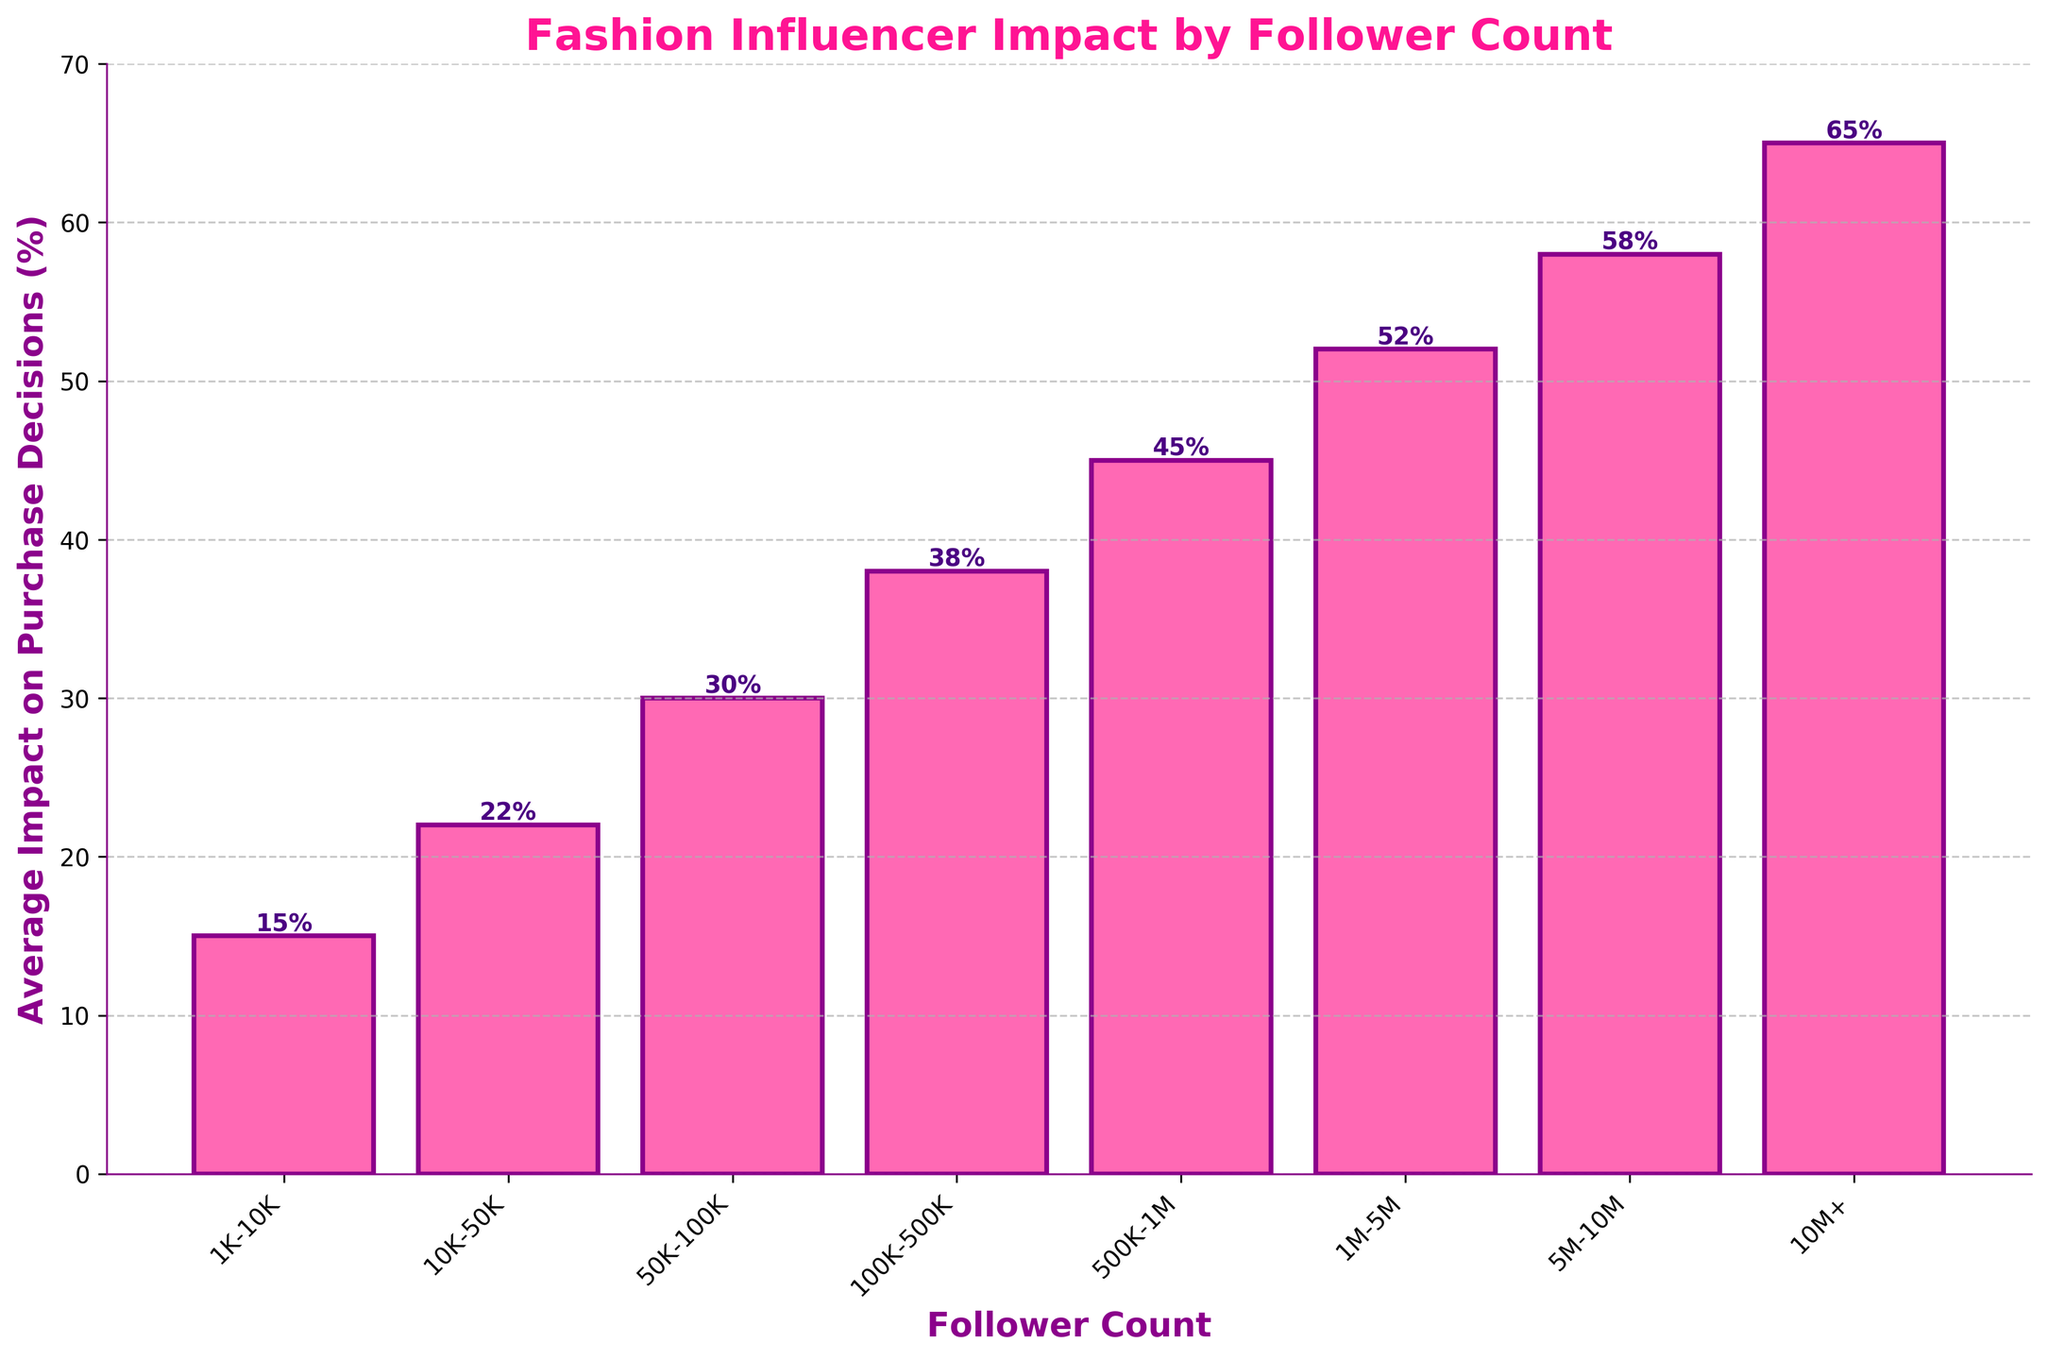What is the average impact on purchase decisions for influencers with 100K-500K followers? The bar representing influencers with 100K-500K followers has a height of 38%, which means the average impact on purchase decisions for this group is 38%.
Answer: 38% Which follower count range has the highest impact on purchase decisions? Looking at the heights of the bars, the bar for the follower count range 10M+ has the highest value at 65%.
Answer: 10M+ How many percentage points higher is the impact for influencers with 1M-5M followers compared to those with 10K-50K followers? The bar for 1M-5M followers shows 52%, and the bar for 10K-50K followers shows 22%. The difference is 52% - 22% = 30%.
Answer: 30% What is the total impact percentage when combining the effect of influencers with 1K-10K and 500K-1M follower counts? The figure shows 15% for 1K-10K followers and 45% for 500K-1M followers. Adding these gives 15% + 45% = 60%.
Answer: 60% Which follower count range shows an impact percentage closest to the median of all provided impact percentages? Listing the percentages: 15, 22, 30, 38, 45, 52, 58, 65. The median is the average of the two middle values (38 and 45). (38+45)/2 = 41.5. The closest range is 100K-500K with 38%.
Answer: 100K-500K Is the impact on purchase decisions of influencers with 5M-10M followers greater than those with 100K-500K followers by more than 20 percentage points? The bar for 5M-10M followers shows 58%, and for 100K-500K followers, it's 38%. The difference is 58% - 38% = 20%, so it is not greater than 20 percentage points.
Answer: No What percentage of influencers with 50K-100K followers have on purchase decisions? The bar for 50K-100K followers indicates an average impact of 30% on purchase decisions.
Answer: 30% Looking at the colors and edge of the bars, which color represents the bar fill and which represents the edge? The bars are filled with pink, and their edges are dark purple.
Answer: Pink for fill, dark purple for edge How does the impact on purchase decisions grow as follower count increases in general from the lowest to the highest count ranges? The bars generally increase in height from left to right, indicating that the average impact on purchase decisions grows as the follower count increases.
Answer: Increasing 